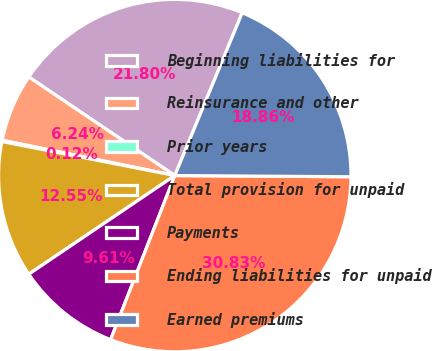Convert chart to OTSL. <chart><loc_0><loc_0><loc_500><loc_500><pie_chart><fcel>Beginning liabilities for<fcel>Reinsurance and other<fcel>Prior years<fcel>Total provision for unpaid<fcel>Payments<fcel>Ending liabilities for unpaid<fcel>Earned premiums<nl><fcel>21.8%<fcel>6.24%<fcel>0.12%<fcel>12.55%<fcel>9.61%<fcel>30.83%<fcel>18.86%<nl></chart> 